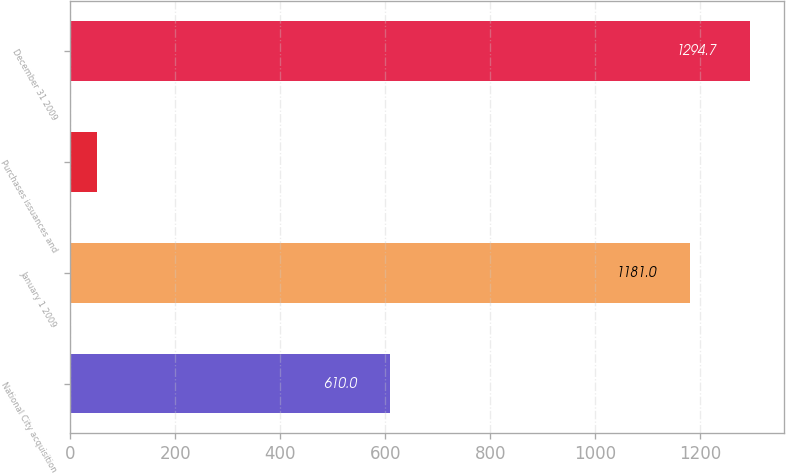Convert chart to OTSL. <chart><loc_0><loc_0><loc_500><loc_500><bar_chart><fcel>National City acquisition<fcel>January 1 2009<fcel>Purchases issuances and<fcel>December 31 2009<nl><fcel>610<fcel>1181<fcel>51<fcel>1294.7<nl></chart> 